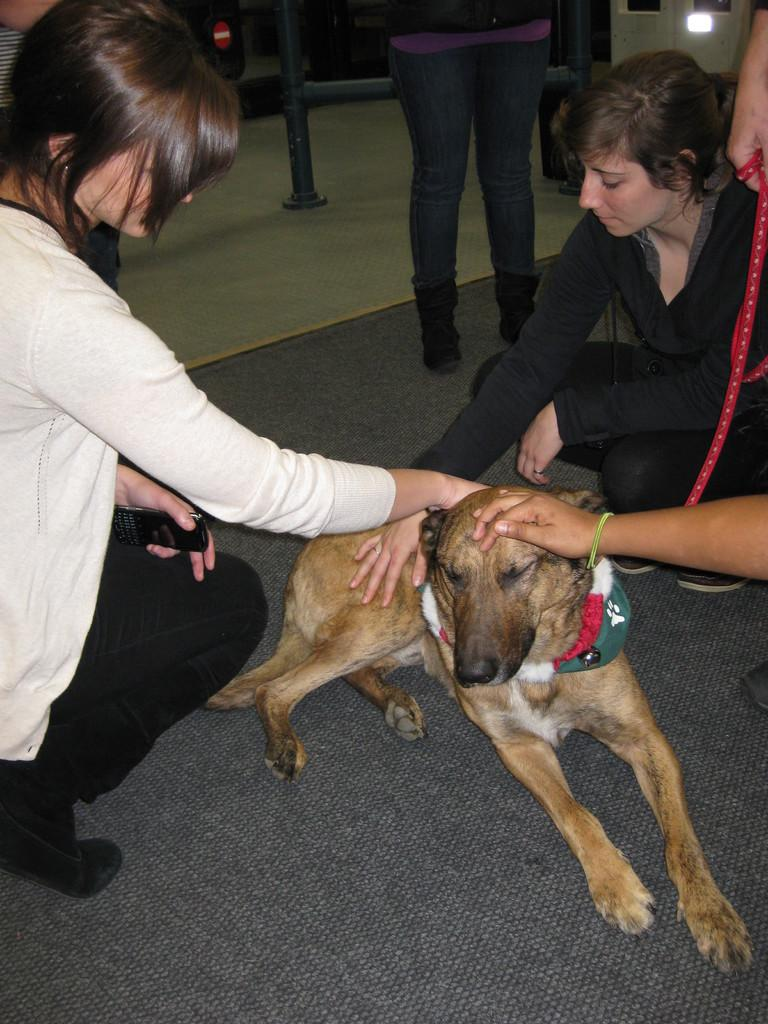How many people are in the image? There are two people in the image. What are the people doing in the image? The two people are sitting on the floor. Is there any other living creature in the image besides the people? Yes, there is a dog in the image. Where is the dog positioned in relation to the people? The dog is between the two people. What time of day is it in the image, and what is the woman wearing? There is no woman present in the image, and the time of day cannot be determined from the image alone. 